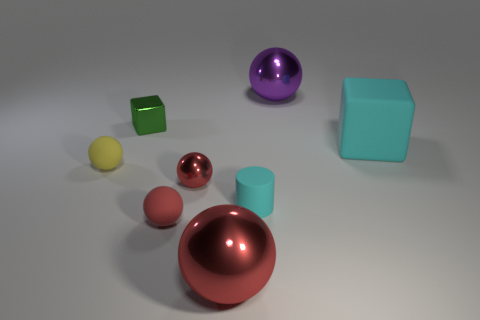Could you describe the lighting in the image? The image is softly lit from what appears to be a source above, casting gentle shadows beneath each object. The lighting accentuates the shapes of the items and allows their colors and textures to be clearly perceived.  Are there any repeating shapes or colors among these objects? Yes, among the objects, there are repeating shapes—there are two cubes and two cylinders. Color repetition can be seen in the two different red-toned spheres, although they differ slightly in hue. 